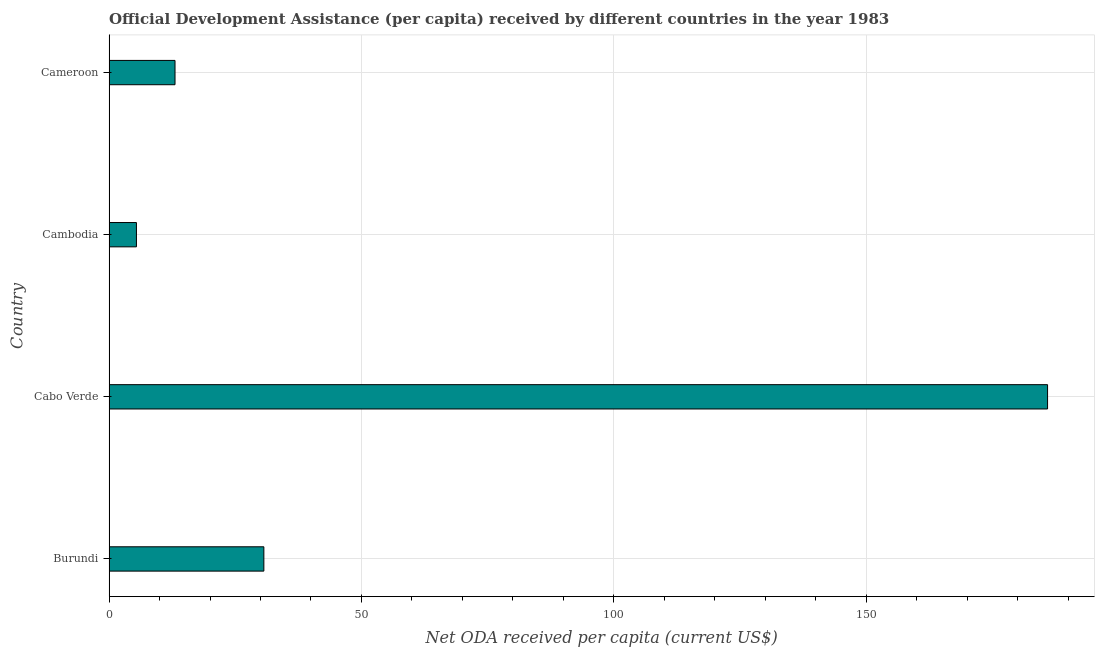Does the graph contain any zero values?
Offer a very short reply. No. What is the title of the graph?
Your answer should be compact. Official Development Assistance (per capita) received by different countries in the year 1983. What is the label or title of the X-axis?
Your answer should be compact. Net ODA received per capita (current US$). What is the net oda received per capita in Cameroon?
Keep it short and to the point. 13.07. Across all countries, what is the maximum net oda received per capita?
Your answer should be compact. 185.95. Across all countries, what is the minimum net oda received per capita?
Make the answer very short. 5.42. In which country was the net oda received per capita maximum?
Your answer should be compact. Cabo Verde. In which country was the net oda received per capita minimum?
Keep it short and to the point. Cambodia. What is the sum of the net oda received per capita?
Provide a succinct answer. 235.11. What is the difference between the net oda received per capita in Cambodia and Cameroon?
Offer a very short reply. -7.64. What is the average net oda received per capita per country?
Make the answer very short. 58.78. What is the median net oda received per capita?
Give a very brief answer. 21.87. In how many countries, is the net oda received per capita greater than 90 US$?
Offer a terse response. 1. What is the ratio of the net oda received per capita in Burundi to that in Cabo Verde?
Keep it short and to the point. 0.17. Is the difference between the net oda received per capita in Burundi and Cabo Verde greater than the difference between any two countries?
Offer a terse response. No. What is the difference between the highest and the second highest net oda received per capita?
Provide a short and direct response. 155.28. Is the sum of the net oda received per capita in Burundi and Cabo Verde greater than the maximum net oda received per capita across all countries?
Ensure brevity in your answer.  Yes. What is the difference between the highest and the lowest net oda received per capita?
Your answer should be very brief. 180.53. In how many countries, is the net oda received per capita greater than the average net oda received per capita taken over all countries?
Your answer should be very brief. 1. How many countries are there in the graph?
Make the answer very short. 4. Are the values on the major ticks of X-axis written in scientific E-notation?
Make the answer very short. No. What is the Net ODA received per capita (current US$) of Burundi?
Provide a succinct answer. 30.67. What is the Net ODA received per capita (current US$) of Cabo Verde?
Give a very brief answer. 185.95. What is the Net ODA received per capita (current US$) in Cambodia?
Keep it short and to the point. 5.42. What is the Net ODA received per capita (current US$) in Cameroon?
Ensure brevity in your answer.  13.07. What is the difference between the Net ODA received per capita (current US$) in Burundi and Cabo Verde?
Provide a succinct answer. -155.28. What is the difference between the Net ODA received per capita (current US$) in Burundi and Cambodia?
Make the answer very short. 25.25. What is the difference between the Net ODA received per capita (current US$) in Burundi and Cameroon?
Make the answer very short. 17.61. What is the difference between the Net ODA received per capita (current US$) in Cabo Verde and Cambodia?
Provide a succinct answer. 180.53. What is the difference between the Net ODA received per capita (current US$) in Cabo Verde and Cameroon?
Ensure brevity in your answer.  172.89. What is the difference between the Net ODA received per capita (current US$) in Cambodia and Cameroon?
Your answer should be compact. -7.64. What is the ratio of the Net ODA received per capita (current US$) in Burundi to that in Cabo Verde?
Offer a very short reply. 0.17. What is the ratio of the Net ODA received per capita (current US$) in Burundi to that in Cambodia?
Your response must be concise. 5.66. What is the ratio of the Net ODA received per capita (current US$) in Burundi to that in Cameroon?
Your answer should be very brief. 2.35. What is the ratio of the Net ODA received per capita (current US$) in Cabo Verde to that in Cambodia?
Offer a terse response. 34.28. What is the ratio of the Net ODA received per capita (current US$) in Cabo Verde to that in Cameroon?
Offer a terse response. 14.23. What is the ratio of the Net ODA received per capita (current US$) in Cambodia to that in Cameroon?
Provide a short and direct response. 0.41. 